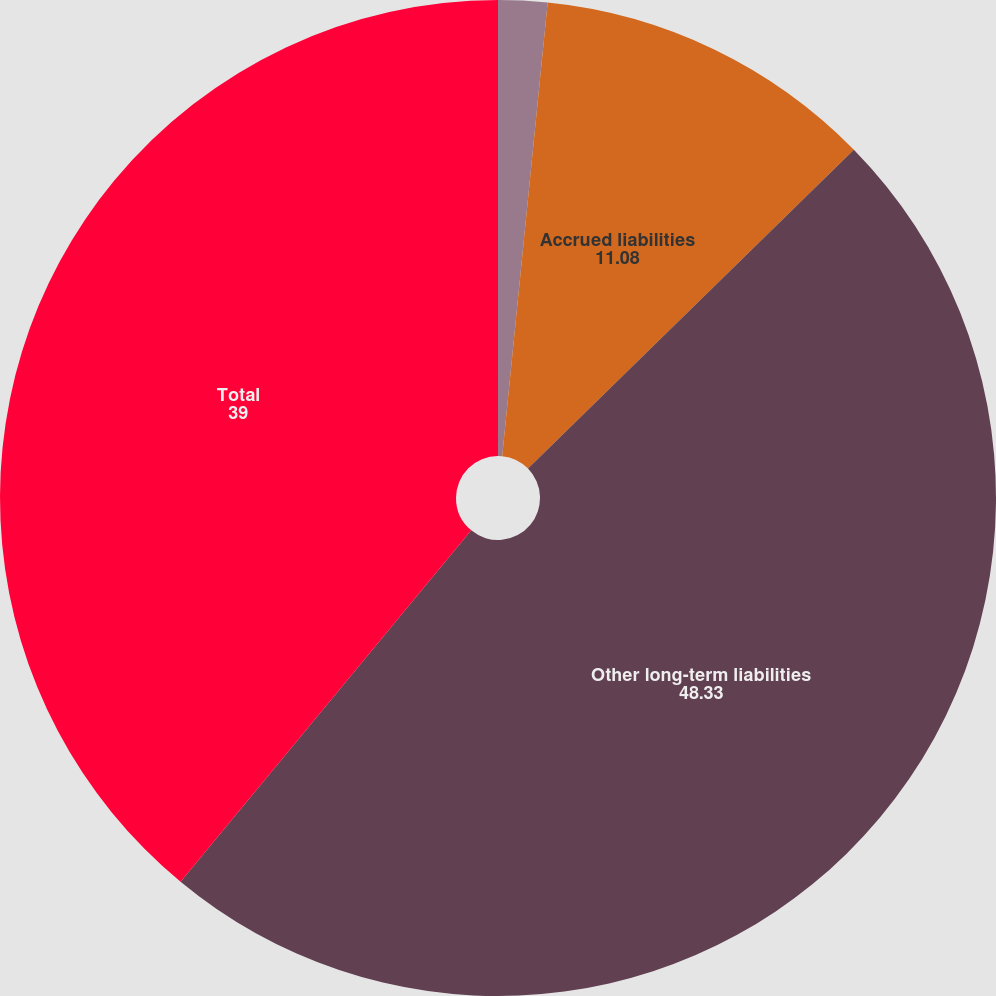Convert chart. <chart><loc_0><loc_0><loc_500><loc_500><pie_chart><fcel>December 31<fcel>Accrued liabilities<fcel>Other long-term liabilities<fcel>Total<nl><fcel>1.59%<fcel>11.08%<fcel>48.33%<fcel>39.0%<nl></chart> 